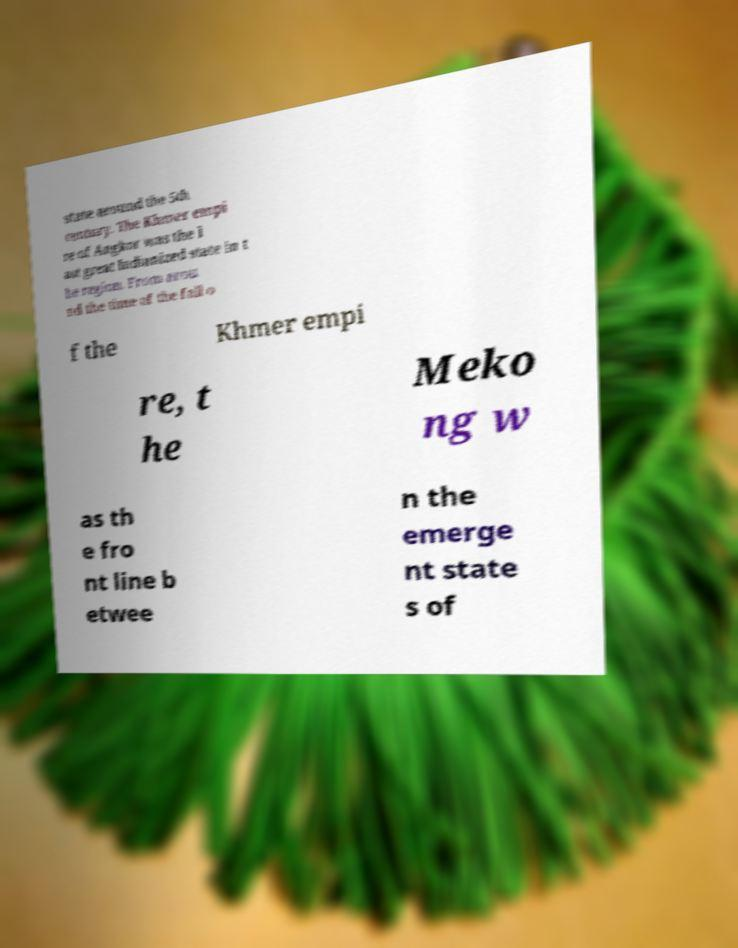Please identify and transcribe the text found in this image. state around the 5th century. The Khmer empi re of Angkor was the l ast great Indianized state in t he region. From arou nd the time of the fall o f the Khmer empi re, t he Meko ng w as th e fro nt line b etwee n the emerge nt state s of 